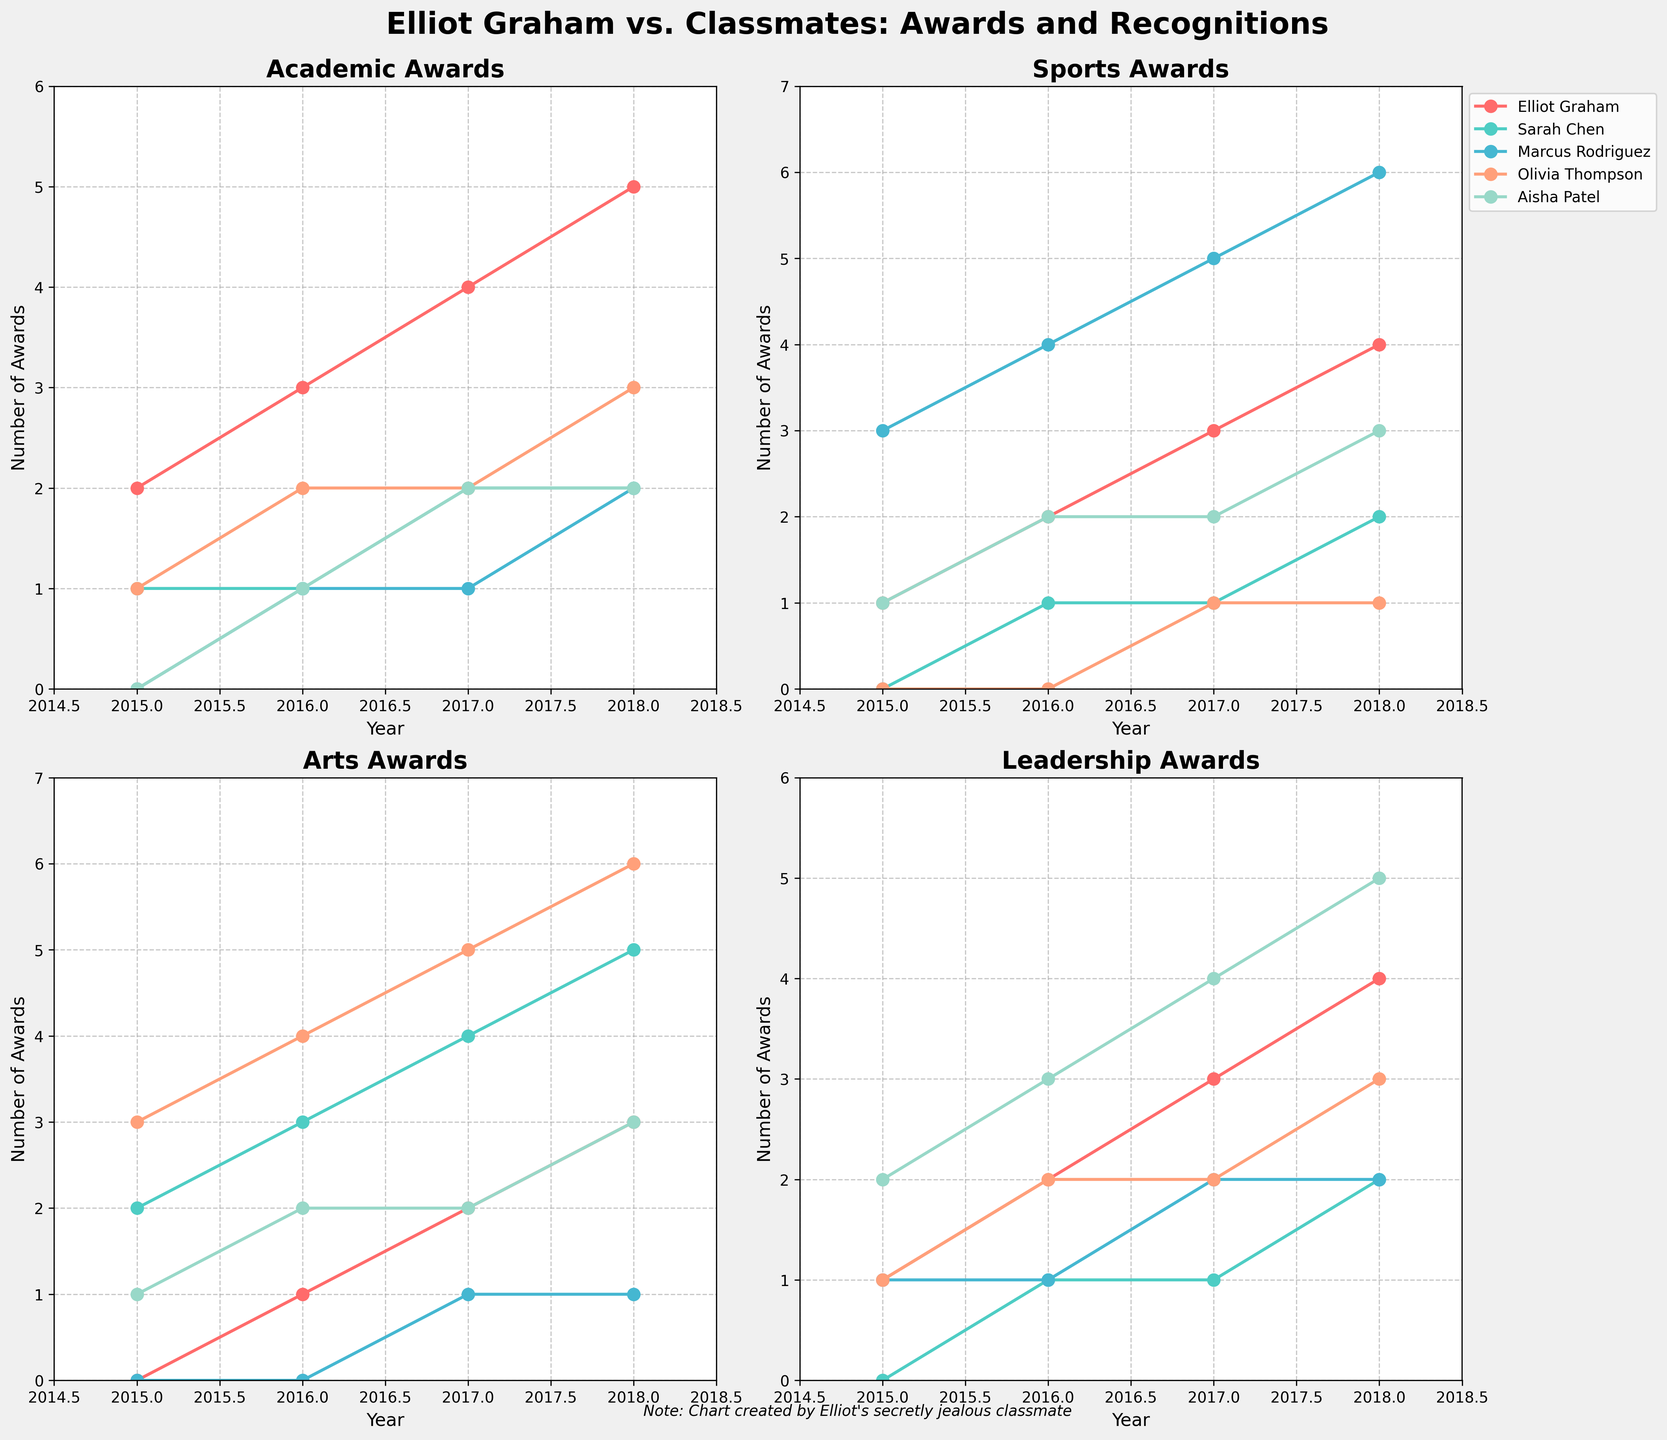what's the title of the figure? The title is usually located at the top of a figure. In this case, it should be large, bold text describing the figure's content.
Answer: Elliot Graham vs. Classmates: Awards and Recognitions what is the vertical axis label of the "Sports Awards" subplot? The axis label specifies the type of data being shown along the axis. For the "Sports Awards" subplot, it should be related to the number of awards received.
Answer: Number of Awards how many awards did Marcus Rodriguez receive in sports in 2016? Find the data point for Marcus Rodriguez for the year 2016 in the "Sports Awards" subplot.
Answer: 4 who received the most academic awards in 2018? Compare the number of academic awards received by each student in 2018.
Answer: Elliot Graham by how much did Sarah Chen's arts awards increase from 2015 to 2018? Subtract the number of arts awards Sarah Chen received in 2015 from the number she received in 2018.
Answer: 3 which student had the most consistent performance across all fields from 2015 to 2018? Look for the student whose lines are the steadiest in their increase or show minimal fluctuations across all subplots.
Answer: Elliot Graham how does Olivia Thompson's performance in leadership compare to her performance in arts? Compare the line representing Olivia Thompson in the "Leadership Awards" subplot to the line in the "Arts Awards" subplot over the years.
Answer: She performs better in arts than in leadership for most years who showed the greatest improvement in academic awards between 2015 and 2018? Calculate the difference in academic awards received between 2015 and 2018 for each student and identify the largest increase.
Answer: Elliot Graham which field saw the highest total number of awards by all students in 2018? Sum the awards for all students in each field in 2018 and compare the totals.
Answer: Academic in which year did Elliot Graham receive the highest total number of awards across all fields? Sum the awards across all fields for Elliot Graham for each year and find the maximum.
Answer: 2018 